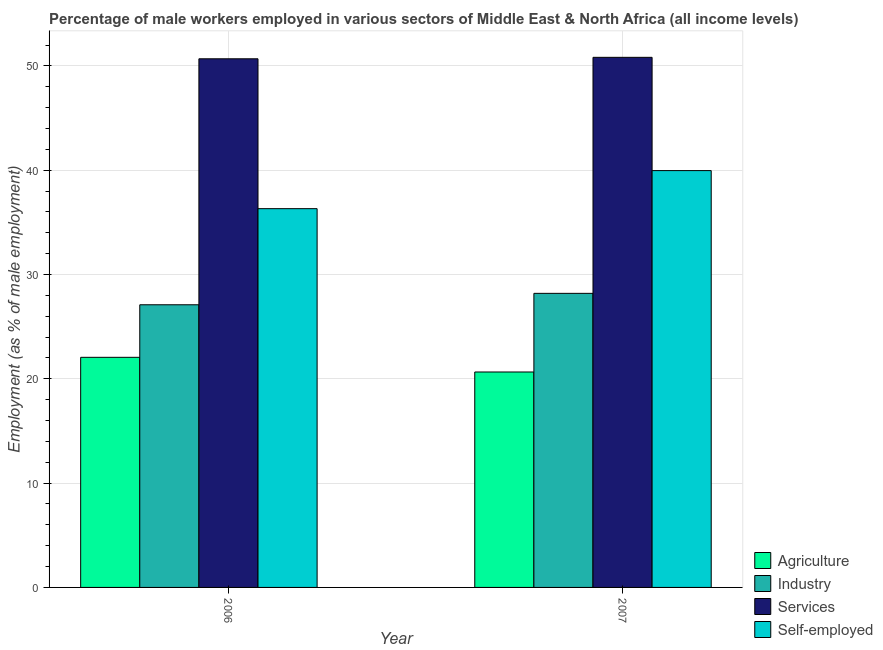How many different coloured bars are there?
Provide a short and direct response. 4. Are the number of bars per tick equal to the number of legend labels?
Keep it short and to the point. Yes. Are the number of bars on each tick of the X-axis equal?
Your answer should be compact. Yes. What is the label of the 2nd group of bars from the left?
Your answer should be compact. 2007. In how many cases, is the number of bars for a given year not equal to the number of legend labels?
Your answer should be very brief. 0. What is the percentage of male workers in services in 2006?
Provide a succinct answer. 50.68. Across all years, what is the maximum percentage of male workers in industry?
Your answer should be compact. 28.19. Across all years, what is the minimum percentage of male workers in services?
Make the answer very short. 50.68. In which year was the percentage of male workers in industry minimum?
Keep it short and to the point. 2006. What is the total percentage of male workers in agriculture in the graph?
Your answer should be very brief. 42.72. What is the difference between the percentage of male workers in industry in 2006 and that in 2007?
Offer a very short reply. -1.1. What is the difference between the percentage of male workers in services in 2007 and the percentage of self employed male workers in 2006?
Give a very brief answer. 0.14. What is the average percentage of male workers in agriculture per year?
Provide a short and direct response. 21.36. In how many years, is the percentage of male workers in agriculture greater than 34 %?
Your response must be concise. 0. What is the ratio of the percentage of male workers in industry in 2006 to that in 2007?
Make the answer very short. 0.96. Is it the case that in every year, the sum of the percentage of male workers in services and percentage of male workers in industry is greater than the sum of percentage of self employed male workers and percentage of male workers in agriculture?
Provide a short and direct response. Yes. What does the 4th bar from the left in 2006 represents?
Keep it short and to the point. Self-employed. What does the 3rd bar from the right in 2006 represents?
Your answer should be very brief. Industry. Is it the case that in every year, the sum of the percentage of male workers in agriculture and percentage of male workers in industry is greater than the percentage of male workers in services?
Offer a very short reply. No. What is the difference between two consecutive major ticks on the Y-axis?
Provide a succinct answer. 10. Does the graph contain grids?
Make the answer very short. Yes. Where does the legend appear in the graph?
Your answer should be compact. Bottom right. How many legend labels are there?
Make the answer very short. 4. What is the title of the graph?
Provide a succinct answer. Percentage of male workers employed in various sectors of Middle East & North Africa (all income levels). Does "Social Protection" appear as one of the legend labels in the graph?
Offer a very short reply. No. What is the label or title of the Y-axis?
Your response must be concise. Employment (as % of male employment). What is the Employment (as % of male employment) in Agriculture in 2006?
Your answer should be compact. 22.06. What is the Employment (as % of male employment) in Industry in 2006?
Your answer should be very brief. 27.1. What is the Employment (as % of male employment) of Services in 2006?
Your answer should be very brief. 50.68. What is the Employment (as % of male employment) in Self-employed in 2006?
Your answer should be compact. 36.31. What is the Employment (as % of male employment) of Agriculture in 2007?
Your answer should be very brief. 20.65. What is the Employment (as % of male employment) of Industry in 2007?
Your answer should be compact. 28.19. What is the Employment (as % of male employment) of Services in 2007?
Keep it short and to the point. 50.82. What is the Employment (as % of male employment) in Self-employed in 2007?
Offer a terse response. 39.96. Across all years, what is the maximum Employment (as % of male employment) in Agriculture?
Ensure brevity in your answer.  22.06. Across all years, what is the maximum Employment (as % of male employment) in Industry?
Provide a succinct answer. 28.19. Across all years, what is the maximum Employment (as % of male employment) of Services?
Give a very brief answer. 50.82. Across all years, what is the maximum Employment (as % of male employment) of Self-employed?
Offer a terse response. 39.96. Across all years, what is the minimum Employment (as % of male employment) of Agriculture?
Offer a very short reply. 20.65. Across all years, what is the minimum Employment (as % of male employment) in Industry?
Ensure brevity in your answer.  27.1. Across all years, what is the minimum Employment (as % of male employment) of Services?
Offer a terse response. 50.68. Across all years, what is the minimum Employment (as % of male employment) in Self-employed?
Ensure brevity in your answer.  36.31. What is the total Employment (as % of male employment) in Agriculture in the graph?
Give a very brief answer. 42.72. What is the total Employment (as % of male employment) in Industry in the graph?
Your answer should be very brief. 55.29. What is the total Employment (as % of male employment) in Services in the graph?
Your answer should be very brief. 101.5. What is the total Employment (as % of male employment) in Self-employed in the graph?
Your answer should be very brief. 76.28. What is the difference between the Employment (as % of male employment) in Agriculture in 2006 and that in 2007?
Your answer should be compact. 1.41. What is the difference between the Employment (as % of male employment) in Industry in 2006 and that in 2007?
Give a very brief answer. -1.1. What is the difference between the Employment (as % of male employment) in Services in 2006 and that in 2007?
Provide a short and direct response. -0.14. What is the difference between the Employment (as % of male employment) of Self-employed in 2006 and that in 2007?
Offer a terse response. -3.65. What is the difference between the Employment (as % of male employment) of Agriculture in 2006 and the Employment (as % of male employment) of Industry in 2007?
Provide a succinct answer. -6.13. What is the difference between the Employment (as % of male employment) of Agriculture in 2006 and the Employment (as % of male employment) of Services in 2007?
Provide a succinct answer. -28.76. What is the difference between the Employment (as % of male employment) in Agriculture in 2006 and the Employment (as % of male employment) in Self-employed in 2007?
Your answer should be compact. -17.9. What is the difference between the Employment (as % of male employment) of Industry in 2006 and the Employment (as % of male employment) of Services in 2007?
Provide a short and direct response. -23.72. What is the difference between the Employment (as % of male employment) in Industry in 2006 and the Employment (as % of male employment) in Self-employed in 2007?
Make the answer very short. -12.86. What is the difference between the Employment (as % of male employment) in Services in 2006 and the Employment (as % of male employment) in Self-employed in 2007?
Offer a terse response. 10.72. What is the average Employment (as % of male employment) in Agriculture per year?
Ensure brevity in your answer.  21.36. What is the average Employment (as % of male employment) in Industry per year?
Your response must be concise. 27.65. What is the average Employment (as % of male employment) in Services per year?
Your response must be concise. 50.75. What is the average Employment (as % of male employment) in Self-employed per year?
Your response must be concise. 38.14. In the year 2006, what is the difference between the Employment (as % of male employment) in Agriculture and Employment (as % of male employment) in Industry?
Keep it short and to the point. -5.04. In the year 2006, what is the difference between the Employment (as % of male employment) in Agriculture and Employment (as % of male employment) in Services?
Your response must be concise. -28.62. In the year 2006, what is the difference between the Employment (as % of male employment) in Agriculture and Employment (as % of male employment) in Self-employed?
Provide a succinct answer. -14.25. In the year 2006, what is the difference between the Employment (as % of male employment) in Industry and Employment (as % of male employment) in Services?
Offer a terse response. -23.58. In the year 2006, what is the difference between the Employment (as % of male employment) of Industry and Employment (as % of male employment) of Self-employed?
Offer a terse response. -9.21. In the year 2006, what is the difference between the Employment (as % of male employment) of Services and Employment (as % of male employment) of Self-employed?
Your response must be concise. 14.37. In the year 2007, what is the difference between the Employment (as % of male employment) of Agriculture and Employment (as % of male employment) of Industry?
Provide a succinct answer. -7.54. In the year 2007, what is the difference between the Employment (as % of male employment) of Agriculture and Employment (as % of male employment) of Services?
Keep it short and to the point. -30.17. In the year 2007, what is the difference between the Employment (as % of male employment) in Agriculture and Employment (as % of male employment) in Self-employed?
Your response must be concise. -19.31. In the year 2007, what is the difference between the Employment (as % of male employment) of Industry and Employment (as % of male employment) of Services?
Provide a succinct answer. -22.63. In the year 2007, what is the difference between the Employment (as % of male employment) of Industry and Employment (as % of male employment) of Self-employed?
Keep it short and to the point. -11.77. In the year 2007, what is the difference between the Employment (as % of male employment) in Services and Employment (as % of male employment) in Self-employed?
Provide a short and direct response. 10.86. What is the ratio of the Employment (as % of male employment) of Agriculture in 2006 to that in 2007?
Your answer should be compact. 1.07. What is the ratio of the Employment (as % of male employment) in Industry in 2006 to that in 2007?
Offer a terse response. 0.96. What is the ratio of the Employment (as % of male employment) of Self-employed in 2006 to that in 2007?
Offer a terse response. 0.91. What is the difference between the highest and the second highest Employment (as % of male employment) of Agriculture?
Your answer should be compact. 1.41. What is the difference between the highest and the second highest Employment (as % of male employment) of Industry?
Your answer should be compact. 1.1. What is the difference between the highest and the second highest Employment (as % of male employment) in Services?
Provide a succinct answer. 0.14. What is the difference between the highest and the second highest Employment (as % of male employment) in Self-employed?
Your response must be concise. 3.65. What is the difference between the highest and the lowest Employment (as % of male employment) in Agriculture?
Provide a short and direct response. 1.41. What is the difference between the highest and the lowest Employment (as % of male employment) of Industry?
Your answer should be compact. 1.1. What is the difference between the highest and the lowest Employment (as % of male employment) in Services?
Provide a succinct answer. 0.14. What is the difference between the highest and the lowest Employment (as % of male employment) in Self-employed?
Your answer should be very brief. 3.65. 